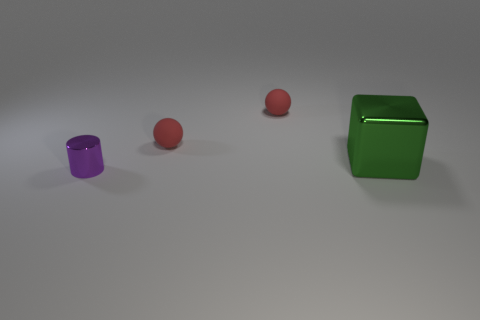Add 2 small purple shiny objects. How many objects exist? 6 Subtract all cylinders. How many objects are left? 3 Add 4 red objects. How many red objects exist? 6 Subtract 0 purple blocks. How many objects are left? 4 Subtract all small green things. Subtract all tiny metallic things. How many objects are left? 3 Add 3 big green cubes. How many big green cubes are left? 4 